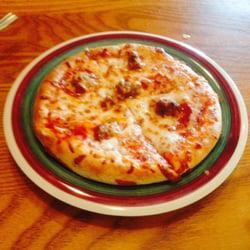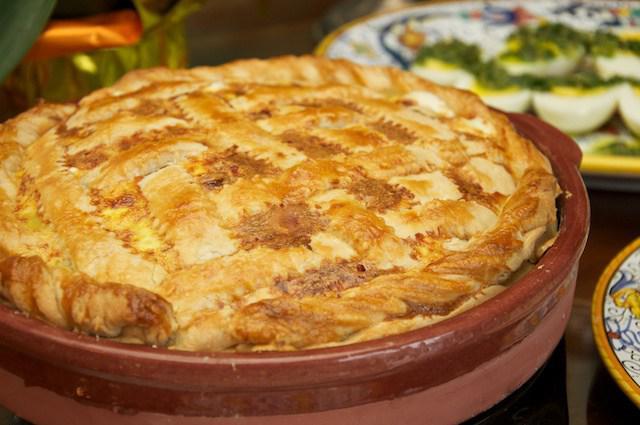The first image is the image on the left, the second image is the image on the right. Given the left and right images, does the statement "The pizza in one of the images sits directly on a wooden paddle." hold true? Answer yes or no. No. The first image is the image on the left, the second image is the image on the right. For the images displayed, is the sentence "There are two full circle pizzas." factually correct? Answer yes or no. No. 